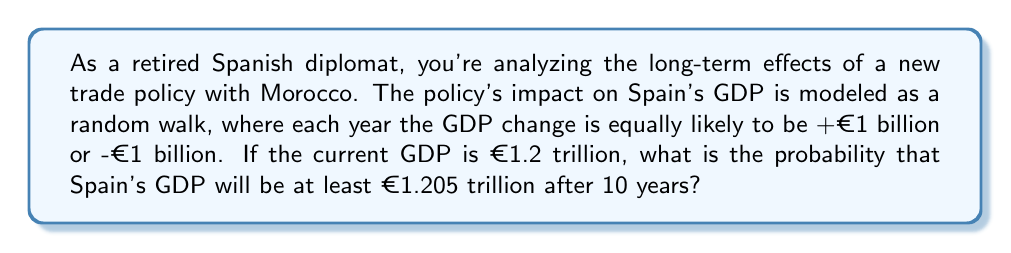Help me with this question. Let's approach this step-by-step:

1) This scenario can be modeled as a one-dimensional random walk. Let $X_n$ be the net change in GDP after $n$ years.

2) After 10 years, $X_{10}$ follows a binomial distribution with parameters $n=10$ and $p=0.5$.

3) We need to find $P(X_{10} \geq 5)$, as a €5 billion increase would bring the GDP to €1.205 trillion.

4) The probability mass function of the binomial distribution is:

   $$P(X=k) = \binom{n}{k} p^k (1-p)^{n-k}$$

5) We need to sum this for all $k \geq 5$:

   $$P(X_{10} \geq 5) = \sum_{k=5}^{10} \binom{10}{k} (0.5)^{10}$$

6) This can be calculated as:

   $$P(X_{10} \geq 5) = 1 - P(X_{10} \leq 4) = 1 - \sum_{k=0}^{4} \binom{10}{k} (0.5)^{10}$$

7) Using the binomial cumulative distribution function or summing manually:

   $$P(X_{10} \geq 5) = 1 - 0.3770 = 0.6230$$

Therefore, the probability is approximately 0.6230 or 62.30%.
Answer: 0.6230 